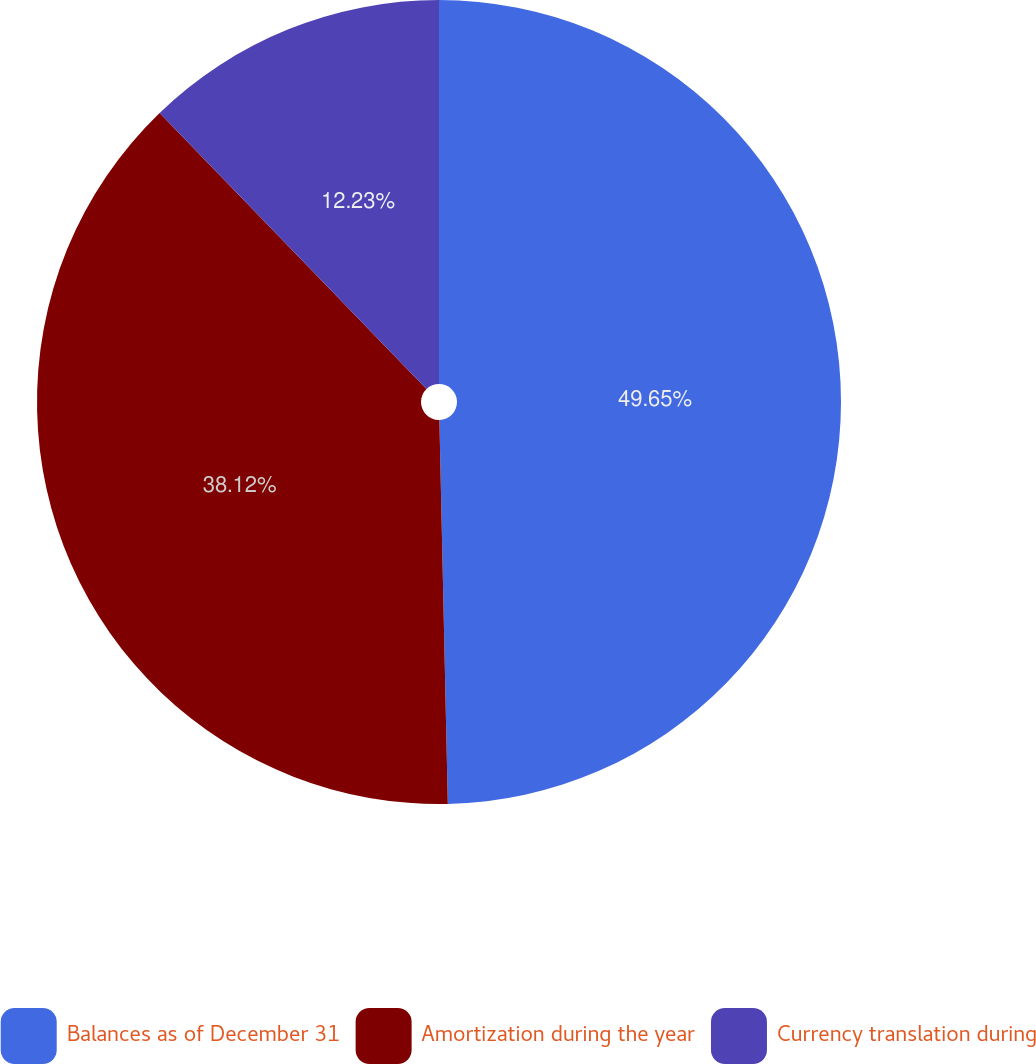Convert chart. <chart><loc_0><loc_0><loc_500><loc_500><pie_chart><fcel>Balances as of December 31<fcel>Amortization during the year<fcel>Currency translation during<nl><fcel>49.65%<fcel>38.12%<fcel>12.23%<nl></chart> 